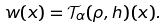Convert formula to latex. <formula><loc_0><loc_0><loc_500><loc_500>w ( x ) = \mathcal { T } _ { \alpha } ( \rho , h ) ( x ) .</formula> 